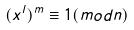<formula> <loc_0><loc_0><loc_500><loc_500>( x ^ { l } ) ^ { m } \equiv 1 ( m o d n )</formula> 